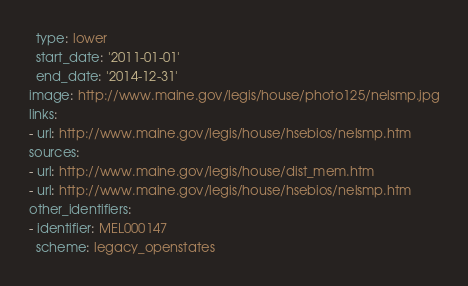Convert code to text. <code><loc_0><loc_0><loc_500><loc_500><_YAML_>  type: lower
  start_date: '2011-01-01'
  end_date: '2014-12-31'
image: http://www.maine.gov/legis/house/photo125/nelsmp.jpg
links:
- url: http://www.maine.gov/legis/house/hsebios/nelsmp.htm
sources:
- url: http://www.maine.gov/legis/house/dist_mem.htm
- url: http://www.maine.gov/legis/house/hsebios/nelsmp.htm
other_identifiers:
- identifier: MEL000147
  scheme: legacy_openstates
</code> 